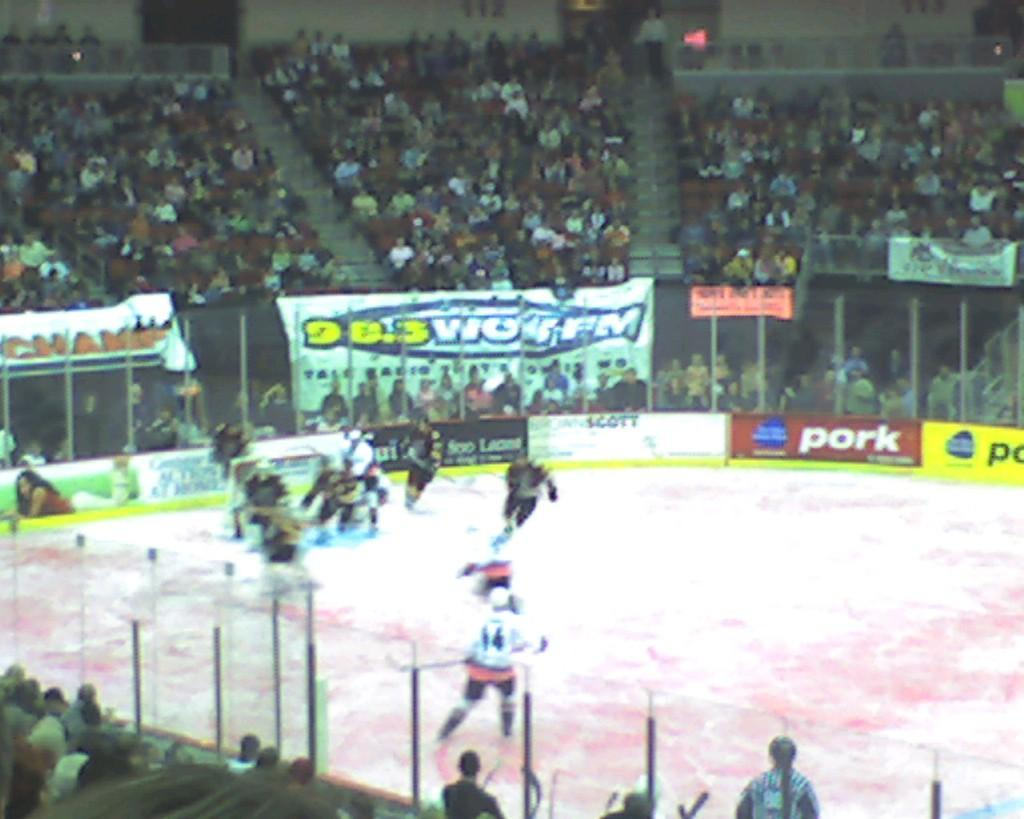<image>
Share a concise interpretation of the image provided. a hockey game on a ring sponsored by 98.3 WOW FM 